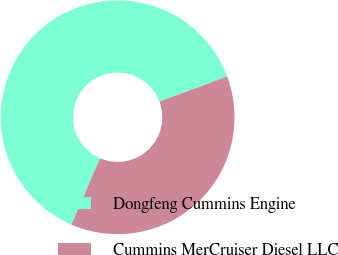<chart> <loc_0><loc_0><loc_500><loc_500><pie_chart><fcel>Dongfeng Cummins Engine<fcel>Cummins MerCruiser Diesel LLC<nl><fcel>62.86%<fcel>37.14%<nl></chart> 